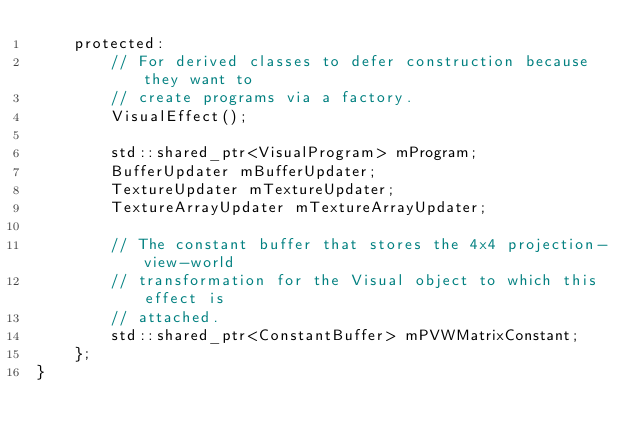<code> <loc_0><loc_0><loc_500><loc_500><_C_>    protected:
        // For derived classes to defer construction because they want to
        // create programs via a factory.
        VisualEffect();

        std::shared_ptr<VisualProgram> mProgram;
        BufferUpdater mBufferUpdater;
        TextureUpdater mTextureUpdater;
        TextureArrayUpdater mTextureArrayUpdater;

        // The constant buffer that stores the 4x4 projection-view-world
        // transformation for the Visual object to which this effect is
        // attached.
        std::shared_ptr<ConstantBuffer> mPVWMatrixConstant;
    };
}
</code> 